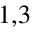<formula> <loc_0><loc_0><loc_500><loc_500>^ { 1 , 3 }</formula> 